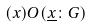<formula> <loc_0><loc_0><loc_500><loc_500>( x ) O ( \underline { x } \colon G )</formula> 